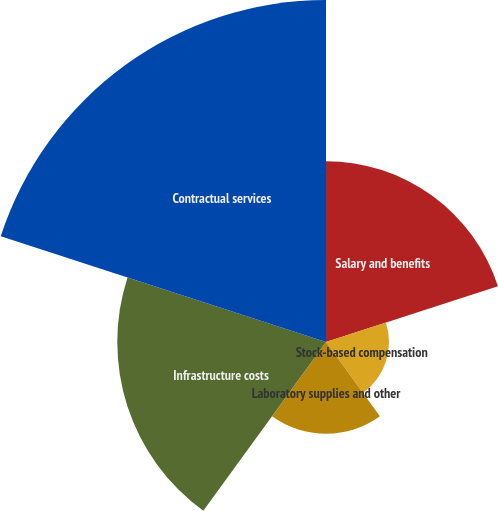Convert chart. <chart><loc_0><loc_0><loc_500><loc_500><pie_chart><fcel>Salary and benefits<fcel>Stock-based compensation<fcel>Laboratory supplies and other<fcel>Infrastructure costs<fcel>Contractual services<nl><fcel>20.4%<fcel>7.11%<fcel>10.35%<fcel>23.55%<fcel>38.59%<nl></chart> 